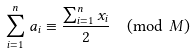<formula> <loc_0><loc_0><loc_500><loc_500>\sum _ { i = 1 } ^ { n } a _ { i } \equiv \frac { \sum _ { i = 1 } ^ { n } x _ { i } } { 2 } \pmod { M }</formula> 